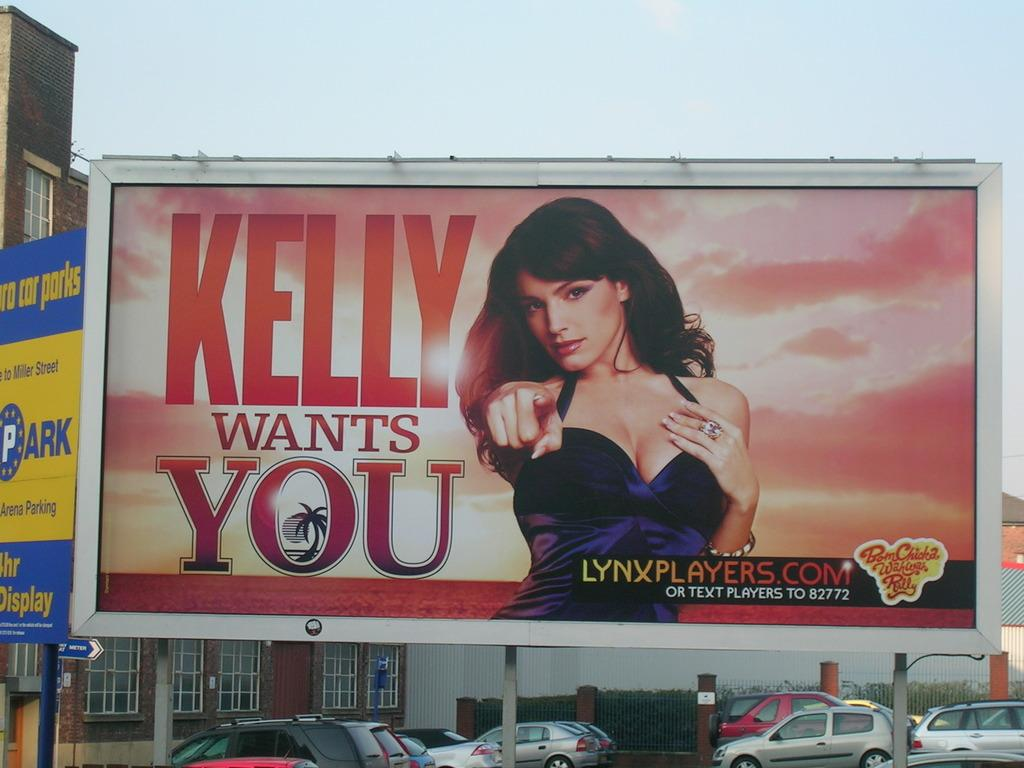<image>
Summarize the visual content of the image. a billboard that says 'kelly wants you' on it 